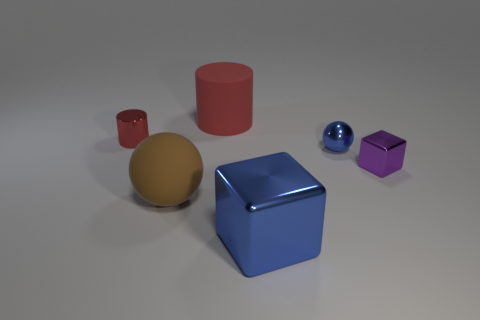Add 1 brown cubes. How many objects exist? 7 Subtract all blocks. How many objects are left? 4 Subtract all green spheres. How many blue cubes are left? 1 Subtract all tiny green metal objects. Subtract all purple things. How many objects are left? 5 Add 6 tiny red objects. How many tiny red objects are left? 7 Add 5 small brown metallic cylinders. How many small brown metallic cylinders exist? 5 Subtract all blue cubes. How many cubes are left? 1 Subtract 0 gray spheres. How many objects are left? 6 Subtract 2 cylinders. How many cylinders are left? 0 Subtract all purple spheres. Subtract all gray cylinders. How many spheres are left? 2 